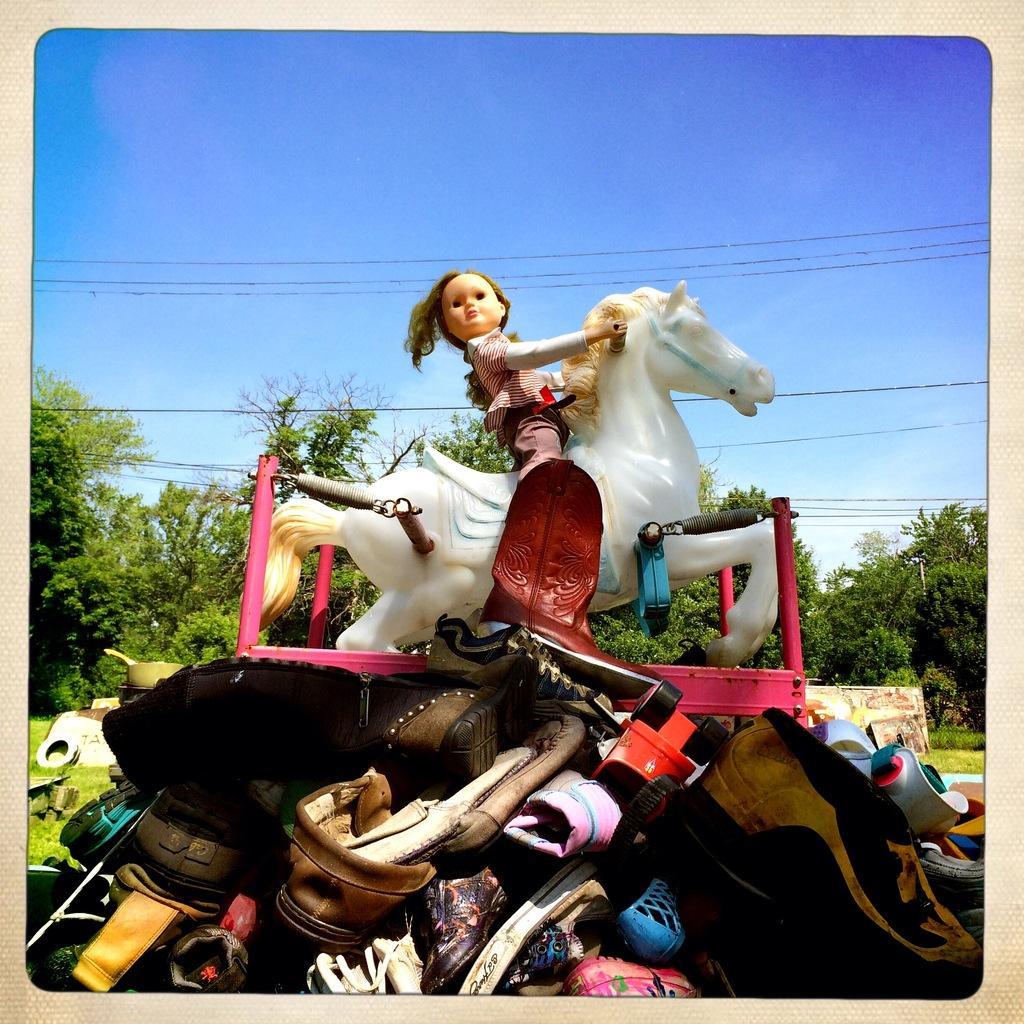Describe this image in one or two sentences. In this image we can see a group of boots and shoes on the ground. We can also see a toy which is placed on them. On the backside we can see a pan, boards, grass, plants, a group of trees, wires and the sky which looks cloudy. 